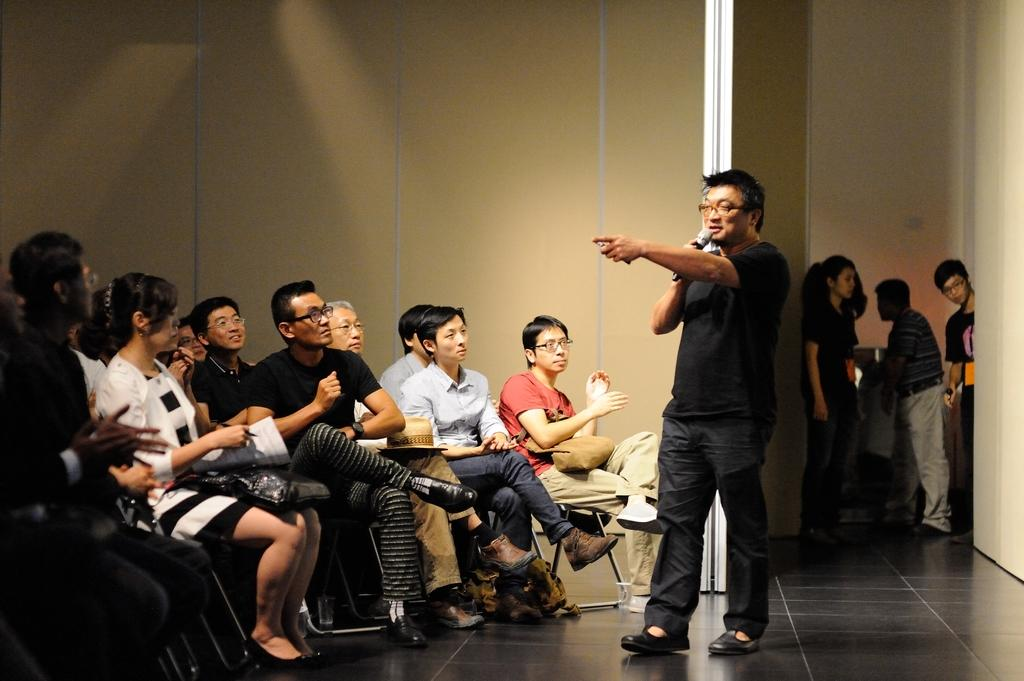What are the people in the image doing? There are people sitting on chairs and standing on the right side of the image. Can you describe the person holding a microphone? The person holding the microphone is talking. What might be the purpose of the microphone? The microphone might be used for amplifying the person's voice during a speech or presentation. What invention is being sold in the shop in the image? There is no shop present in the image, so it is not possible to determine what invention might be sold. 